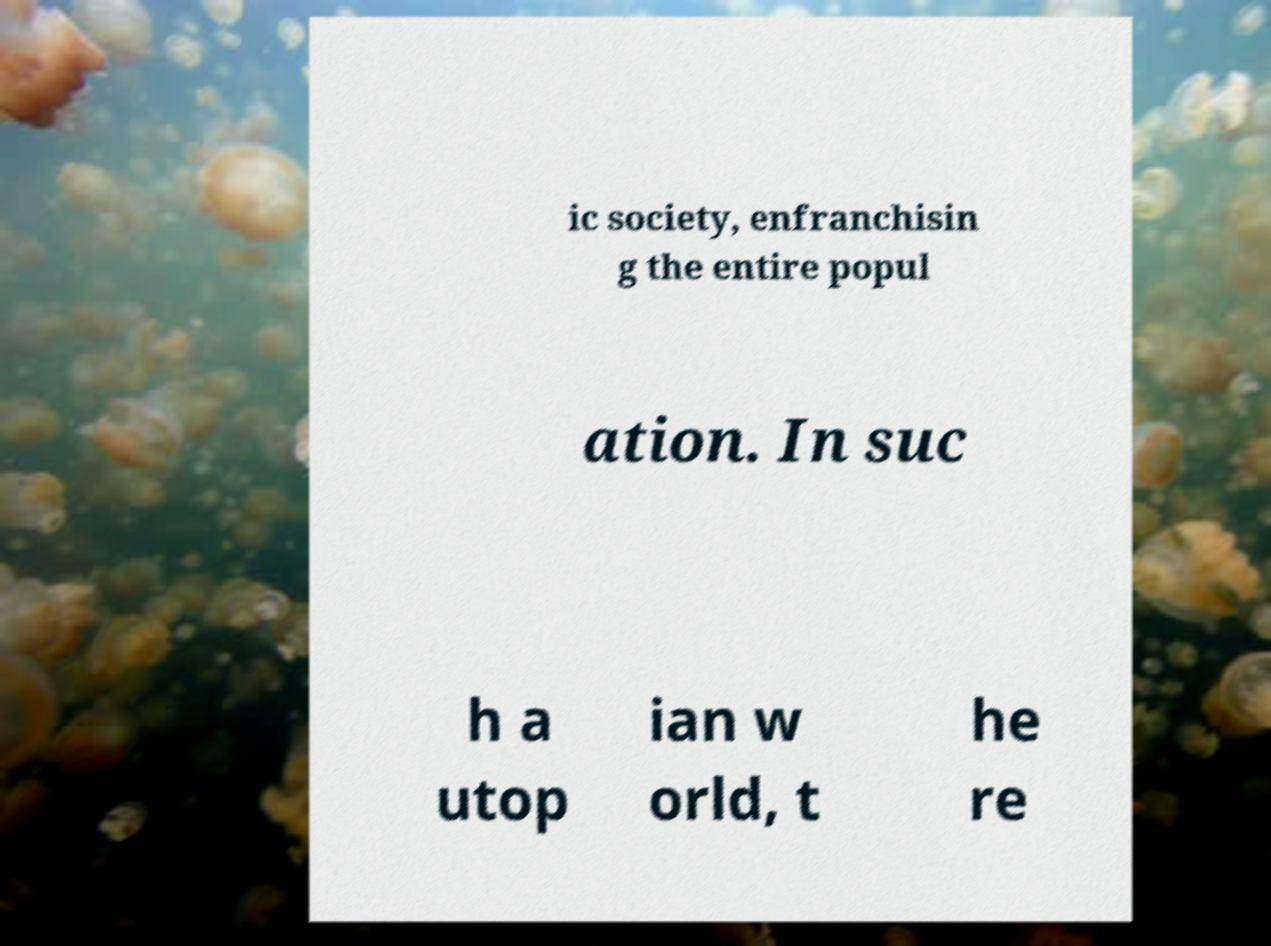What messages or text are displayed in this image? I need them in a readable, typed format. ic society, enfranchisin g the entire popul ation. In suc h a utop ian w orld, t he re 